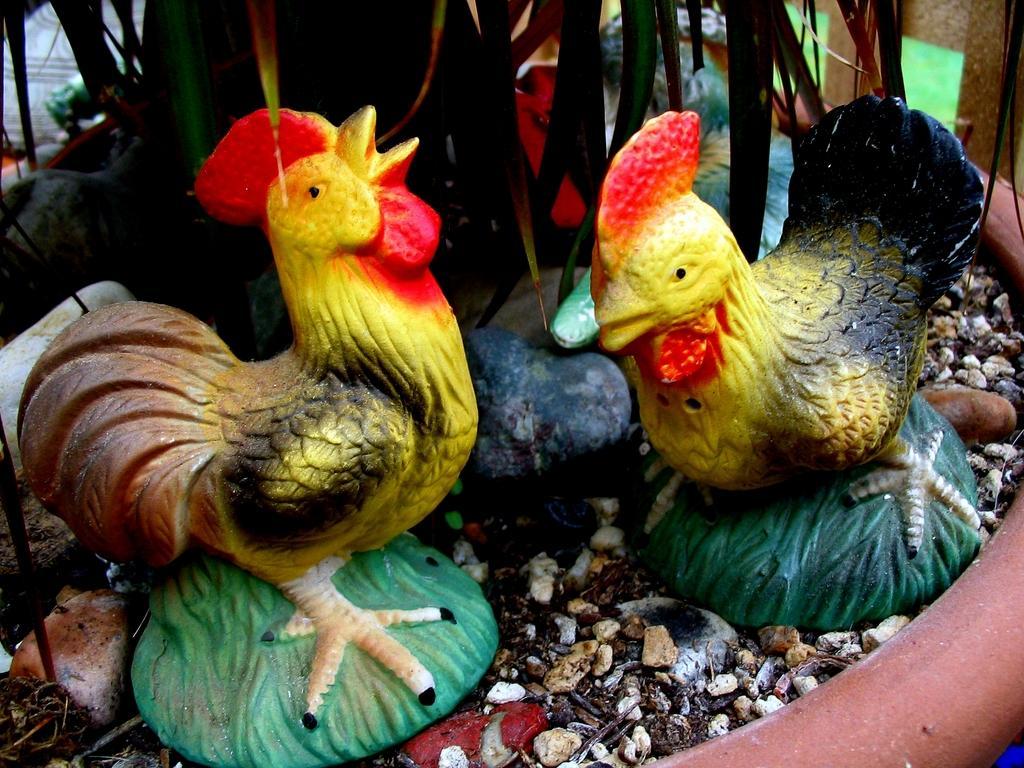Describe this image in one or two sentences. This picture seems to be clicked inside. In the foreground we can see the gravels and the sculptures of two birds. In the background we can see the leaves and some other objects. 